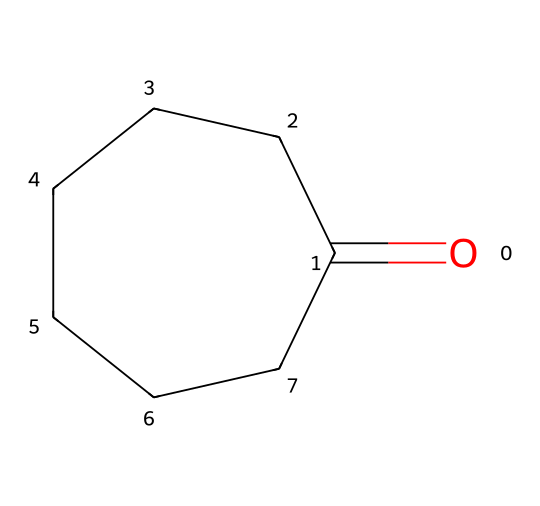What is the carbon count in cycloheptanone? The SMILES representation shows seven carbon atoms forming a cyclic structure, indicated by the notation C1CCCCCC1. Thus, the total count of carbon atoms is seven.
Answer: seven How many hydrogen atoms are in cycloheptanone? In cycloheptanone, for every carbon atom, generally two hydrogen atoms are bonded. However, due to the presence of a ketone (double-bonded oxygen), one hydrogen from the carbon atom adjacent to the carbonyl is removed. The formula for determining hydrogen count is C_nH_(2n-2) for cyclic alkanes. Thus, for seven carbons, it is 2(7) - 2 = 12 hydrogen atoms.
Answer: twelve What functional group is present in cycloheptanone? The structure contains a carbonyl group resulting from the O=C (double bond with oxygen), which identifies it as a ketone.
Answer: ketone Is cycloheptanone classified as a saturated or unsaturated compound? Since all the carbon atoms are single-bonded besides the one carbon bonded with double-bonded oxygen, it does not have any double or triple carbon-carbon bonds, making it a saturated compound.
Answer: saturated What cycloalkane structure does cycloheptanone exhibit? The chemical structure is a seven-membered ring, as indicated by the number of carbon atoms (C1 to C7 in the SMILES) forming a single cycle.
Answer: seven-membered ring Why might cycloheptanone be selected for tissue engineering applications? Its cyclic structure can provide unique mechanical properties and stability required in biomaterials, while the presence of a carbonyl group can facilitate reactions relevant for creating biocompatible materials.
Answer: mechanical properties and stability 